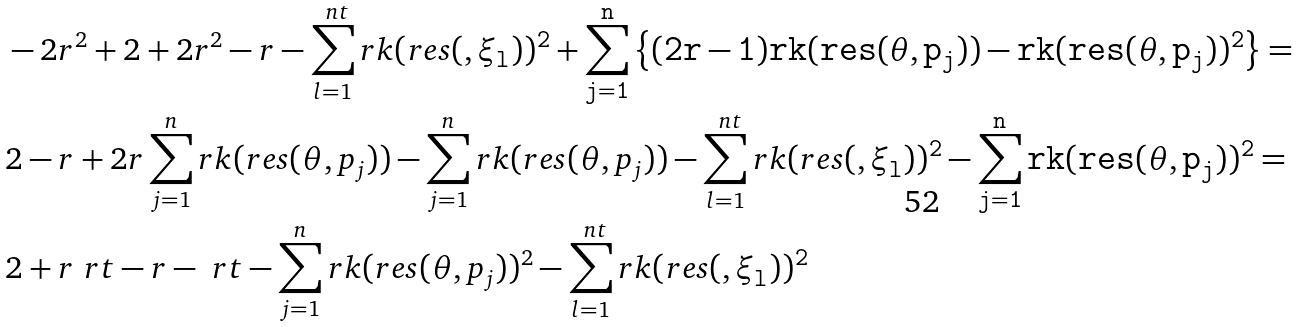<formula> <loc_0><loc_0><loc_500><loc_500>& - 2 r ^ { 2 } + 2 + 2 r ^ { 2 } - r - \sum _ { l = 1 } ^ { \ n t } r k ( r e s ( \tt , \xi _ { l } ) ) ^ { 2 } + \sum _ { j = 1 } ^ { n } \left \{ ( 2 r - 1 ) r k ( r e s ( \theta , p _ { j } ) ) - r k ( r e s ( \theta , p _ { j } ) ) ^ { 2 } \right \} = \\ & 2 - r + 2 r \sum _ { j = 1 } ^ { n } r k ( r e s ( \theta , p _ { j } ) ) - \sum _ { j = 1 } ^ { n } r k ( r e s ( \theta , p _ { j } ) ) - \sum _ { l = 1 } ^ { \ n t } r k ( r e s ( \tt , \xi _ { l } ) ) ^ { 2 } - \sum _ { j = 1 } ^ { n } r k ( r e s ( \theta , p _ { j } ) ) ^ { 2 } = \\ & 2 + r \ r t - r - \ r t - \sum _ { j = 1 } ^ { n } r k ( r e s ( \theta , p _ { j } ) ) ^ { 2 } - \sum _ { l = 1 } ^ { \ n t } r k ( r e s ( \tt , \xi _ { l } ) ) ^ { 2 }</formula> 